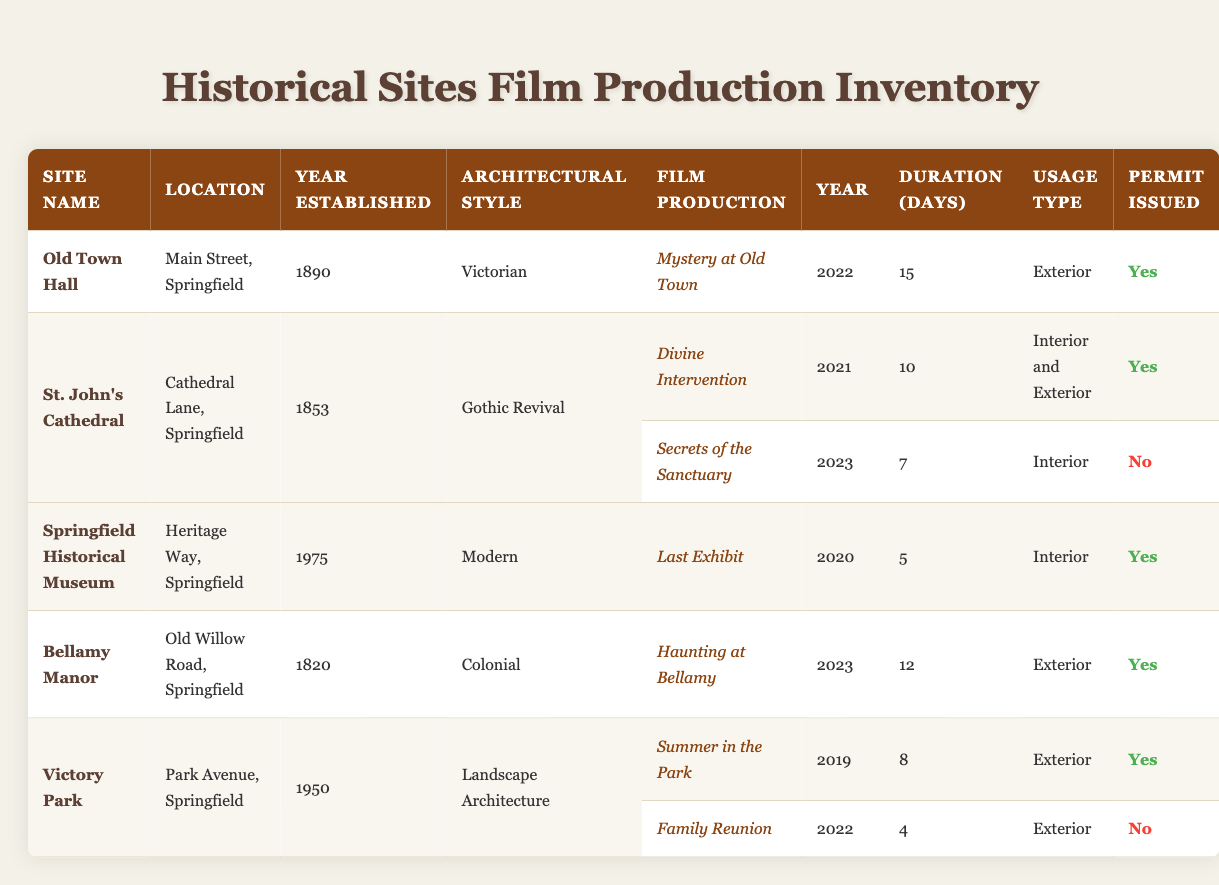What is the location of Old Town Hall? The location of Old Town Hall is specified in the table as "Main Street, Springfield."
Answer: Main Street, Springfield How many days did the production "Divine Intervention" use St. John’s Cathedral? The table indicates that "Divine Intervention" used St. John’s Cathedral for 10 days.
Answer: 10 days Which historical site was established most recently? By checking the "Year Established" column, Springfield Historical Museum was established in 1975, which is the most recent among the listed sites.
Answer: Springfield Historical Museum Did "Secrets of the Sanctuary" receive a permit? The permit status for "Secrets of the Sanctuary" is noted as "No" in the table.
Answer: No What is the total duration of film productions at Victory Park? The durations for the productions at Victory Park are 8 days ("Summer in the Park") and 4 days ("Family Reunion"). Adding these gives 8 + 4 = 12 days total.
Answer: 12 days Are any exterior permits issued for "Family Reunion" at Victory Park? The table shows that "Family Reunion" did not receive a permit, indicated by "No" in the Permit Issued column.
Answer: No How many historical sites have had a permit issued for their film productions? By checking the table, permits were issued for "Old Town Hall," "Divine Intervention," "Last Exhibit," "Haunting at Bellamy," and "Summer in the Park," totaling 4 sites.
Answer: 4 sites Which site had the longest film production duration? Comparing the duration of film productions, "Mystery at Old Town" at Old Town Hall had a duration of 15 days, which is the longest noted in the table.
Answer: Old Town Hall, 15 days What architectural style is associated with Bellamy Manor? The table specifies that Bellamy Manor is in the "Colonial" architectural style.
Answer: Colonial Is there any film production at St. John’s Cathedral in 2023? The table confirms that "Secrets of the Sanctuary," a production at St. John's Cathedral, took place in 2023.
Answer: Yes What is the average duration of film productions for St. John's Cathedral? The durations for St. John's Cathedral are 10 days for "Divine Intervention" and 7 days for "Secrets of the Sanctuary." The average is (10 + 7) / 2 = 8.5 days.
Answer: 8.5 days Which site has the earliest establishment year? The earliest establishment year, found in the table, is 1820 for Bellamy Manor, making it the earliest site.
Answer: Bellamy Manor, 1820 How many film productions took place in total at Springfield Historical Museum? The table shows that only 1 production, "Last Exhibit," occurred at Springfield Historical Museum.
Answer: 1 production Did Victory Park have any productions with unissued permits? Yes, the table indicates that "Family Reunion" at Victory Park did not have a permit issued, marked by "No."
Answer: Yes What is the total number of film productions listed for all sites combined? By counting the film productions listed under each site, there are a total of 7 separate productions across the sites.
Answer: 7 productions 